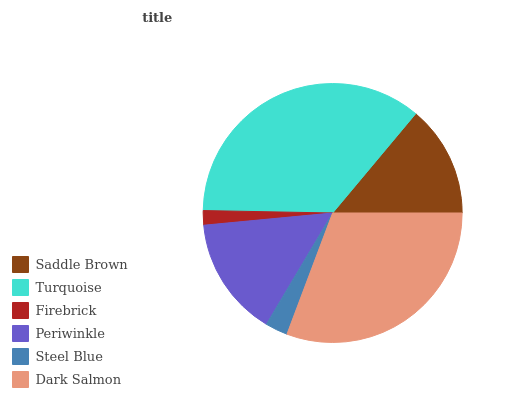Is Firebrick the minimum?
Answer yes or no. Yes. Is Turquoise the maximum?
Answer yes or no. Yes. Is Turquoise the minimum?
Answer yes or no. No. Is Firebrick the maximum?
Answer yes or no. No. Is Turquoise greater than Firebrick?
Answer yes or no. Yes. Is Firebrick less than Turquoise?
Answer yes or no. Yes. Is Firebrick greater than Turquoise?
Answer yes or no. No. Is Turquoise less than Firebrick?
Answer yes or no. No. Is Periwinkle the high median?
Answer yes or no. Yes. Is Saddle Brown the low median?
Answer yes or no. Yes. Is Firebrick the high median?
Answer yes or no. No. Is Periwinkle the low median?
Answer yes or no. No. 